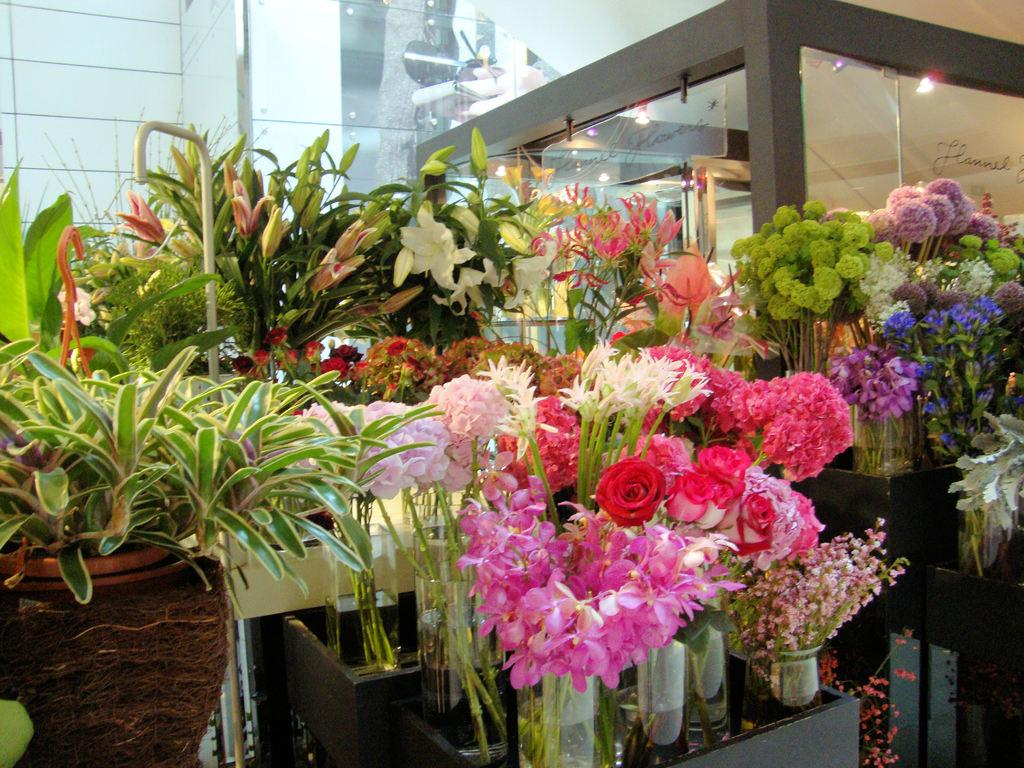What type of plants can be seen in the image? There are flower plants in the image. What is visible in the background of the image? There is a glass wall in the background of the image. Where is the pot located in the image? The pot is in the bottom left of the image. What is the price of the beggar's services in the image? There is no beggar present in the image, so it is not possible to determine the price of their services. 